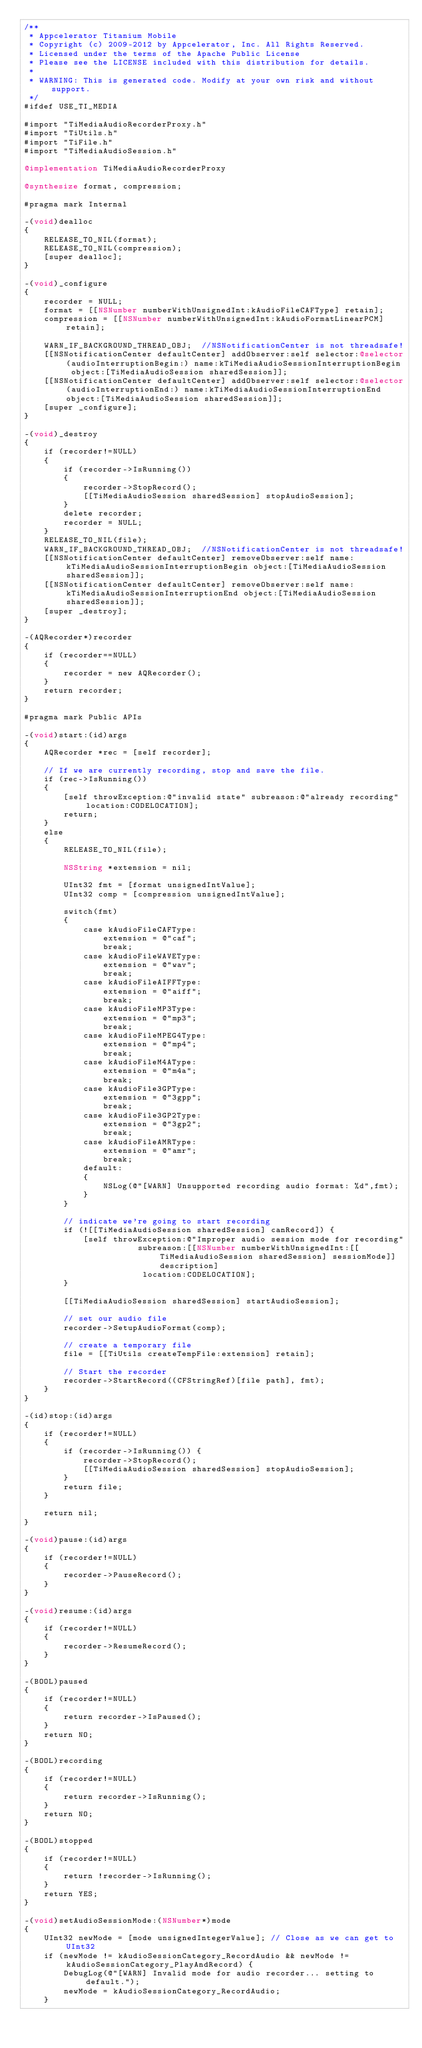Convert code to text. <code><loc_0><loc_0><loc_500><loc_500><_ObjectiveC_>/**
 * Appcelerator Titanium Mobile
 * Copyright (c) 2009-2012 by Appcelerator, Inc. All Rights Reserved.
 * Licensed under the terms of the Apache Public License
 * Please see the LICENSE included with this distribution for details.
 * 
 * WARNING: This is generated code. Modify at your own risk and without support.
 */
#ifdef USE_TI_MEDIA

#import "TiMediaAudioRecorderProxy.h"
#import "TiUtils.h"
#import "TiFile.h"
#import "TiMediaAudioSession.h"

@implementation TiMediaAudioRecorderProxy

@synthesize format, compression;

#pragma mark Internal 

-(void)dealloc
{
	RELEASE_TO_NIL(format);
	RELEASE_TO_NIL(compression);
	[super dealloc];
}

-(void)_configure
{
	recorder = NULL;
	format = [[NSNumber numberWithUnsignedInt:kAudioFileCAFType] retain];
	compression = [[NSNumber numberWithUnsignedInt:kAudioFormatLinearPCM] retain];
	
	WARN_IF_BACKGROUND_THREAD_OBJ;	//NSNotificationCenter is not threadsafe!
	[[NSNotificationCenter defaultCenter] addObserver:self selector:@selector(audioInterruptionBegin:) name:kTiMediaAudioSessionInterruptionBegin object:[TiMediaAudioSession sharedSession]];
	[[NSNotificationCenter defaultCenter] addObserver:self selector:@selector(audioInterruptionEnd:) name:kTiMediaAudioSessionInterruptionEnd object:[TiMediaAudioSession sharedSession]];
	[super _configure];
}

-(void)_destroy
{
	if (recorder!=NULL)
	{
		if (recorder->IsRunning())
		{
			recorder->StopRecord();
			[[TiMediaAudioSession sharedSession] stopAudioSession];
		}
		delete recorder;
		recorder = NULL;
	}
	RELEASE_TO_NIL(file);
	WARN_IF_BACKGROUND_THREAD_OBJ;	//NSNotificationCenter is not threadsafe!
	[[NSNotificationCenter defaultCenter] removeObserver:self name:kTiMediaAudioSessionInterruptionBegin object:[TiMediaAudioSession sharedSession]];
	[[NSNotificationCenter defaultCenter] removeObserver:self name:kTiMediaAudioSessionInterruptionEnd object:[TiMediaAudioSession sharedSession]];
	[super _destroy];
}

-(AQRecorder*)recorder
{
	if (recorder==NULL)
	{
		recorder = new AQRecorder();
	}
	return recorder;
}

#pragma mark Public APIs 

-(void)start:(id)args
{
	AQRecorder *rec = [self recorder];
	
	// If we are currently recording, stop and save the file.
	if (rec->IsRunning()) 
	{
		[self throwException:@"invalid state" subreason:@"already recording" location:CODELOCATION];
		return;
	}
	else
	{
		RELEASE_TO_NIL(file);
		
		NSString *extension = nil;
		
		UInt32 fmt = [format unsignedIntValue];
		UInt32 comp = [compression unsignedIntValue];
		
		switch(fmt)
		{
			case kAudioFileCAFType:
				extension = @"caf";
				break;
			case kAudioFileWAVEType:
				extension = @"wav";
				break;
			case kAudioFileAIFFType:
				extension = @"aiff";
				break;
			case kAudioFileMP3Type:
				extension = @"mp3";
				break;
			case kAudioFileMPEG4Type:
				extension = @"mp4";
				break;
			case kAudioFileM4AType:
				extension = @"m4a";
				break;
			case kAudioFile3GPType:
				extension = @"3gpp";
				break;
			case kAudioFile3GP2Type:
				extension = @"3gp2";
				break;
			case kAudioFileAMRType:
				extension = @"amr";
				break;
			default:
			{
				NSLog(@"[WARN] Unsupported recording audio format: %d",fmt);
			}
		}
		
		// indicate we're going to start recording
		if (![[TiMediaAudioSession sharedSession] canRecord]) {
			[self throwException:@"Improper audio session mode for recording"
					   subreason:[[NSNumber numberWithUnsignedInt:[[TiMediaAudioSession sharedSession] sessionMode]] description]
						location:CODELOCATION];
		}
		
		[[TiMediaAudioSession sharedSession] startAudioSession];
		
		// set our audio file
		recorder->SetupAudioFormat(comp);
		
		// create a temporary file
		file = [[TiUtils createTempFile:extension] retain];
		
		// Start the recorder
		recorder->StartRecord((CFStringRef)[file path], fmt);
	}
}

-(id)stop:(id)args
{
	if (recorder!=NULL)
	{
		if (recorder->IsRunning()) {
			recorder->StopRecord();
			[[TiMediaAudioSession sharedSession] stopAudioSession];
		}
		return file;
	}
	
	return nil;
}

-(void)pause:(id)args
{
	if (recorder!=NULL)
	{
		recorder->PauseRecord();
	}
}

-(void)resume:(id)args
{
	if (recorder!=NULL)
	{
		recorder->ResumeRecord();
	}
}

-(BOOL)paused
{
	if (recorder!=NULL)
	{
		return recorder->IsPaused();
	}
	return NO;
}

-(BOOL)recording
{
	if (recorder!=NULL)
	{
		return recorder->IsRunning();
	}
	return NO;
}

-(BOOL)stopped
{
	if (recorder!=NULL)
	{
		return !recorder->IsRunning();
	}
	return YES;
}

-(void)setAudioSessionMode:(NSNumber*)mode
{
    UInt32 newMode = [mode unsignedIntegerValue]; // Close as we can get to UInt32
    if (newMode != kAudioSessionCategory_RecordAudio && newMode != kAudioSessionCategory_PlayAndRecord) {
        DebugLog(@"[WARN] Invalid mode for audio recorder... setting to default.");
        newMode = kAudioSessionCategory_RecordAudio;
    }</code> 